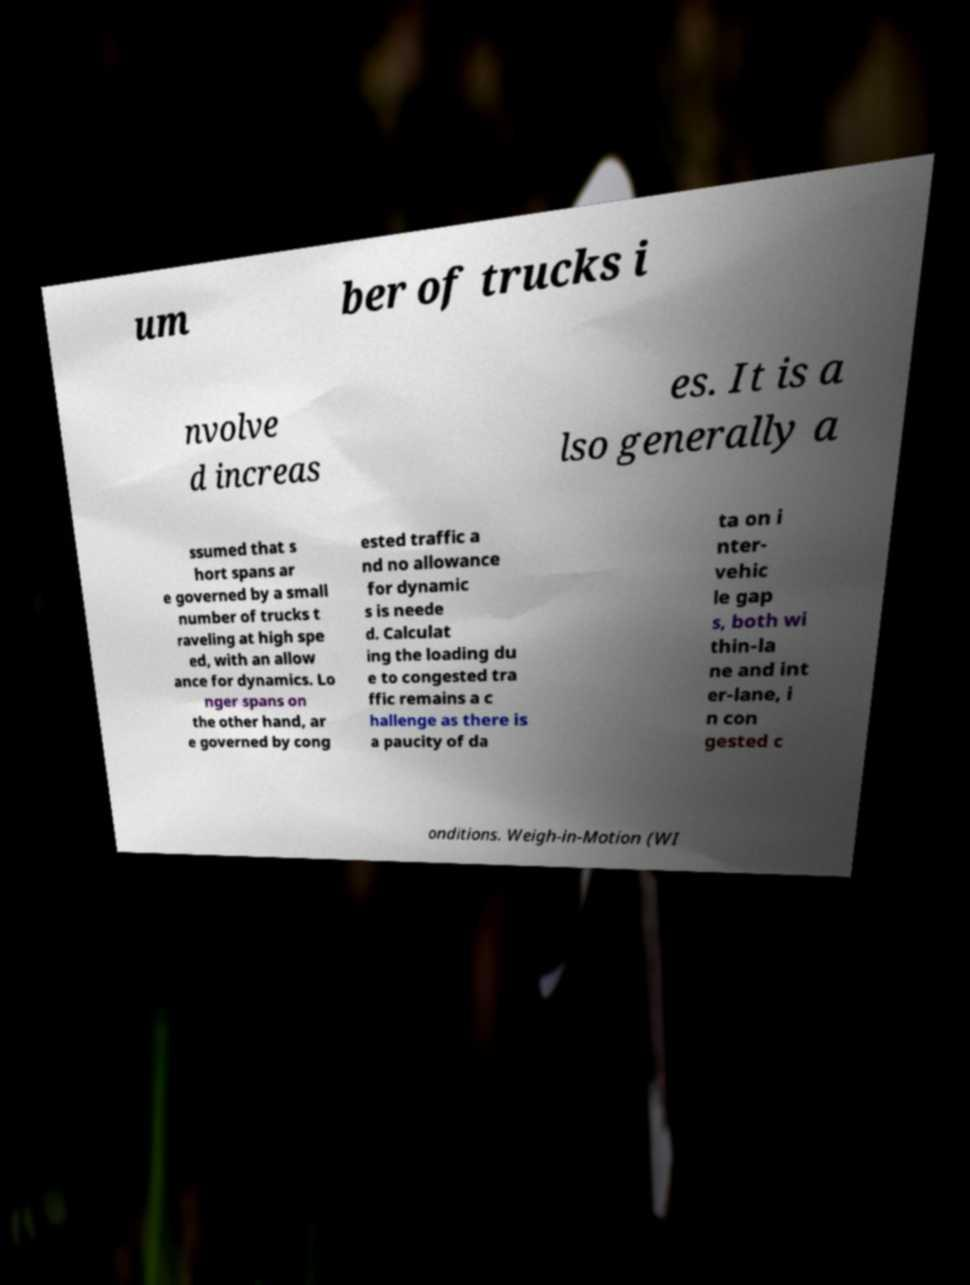What messages or text are displayed in this image? I need them in a readable, typed format. um ber of trucks i nvolve d increas es. It is a lso generally a ssumed that s hort spans ar e governed by a small number of trucks t raveling at high spe ed, with an allow ance for dynamics. Lo nger spans on the other hand, ar e governed by cong ested traffic a nd no allowance for dynamic s is neede d. Calculat ing the loading du e to congested tra ffic remains a c hallenge as there is a paucity of da ta on i nter- vehic le gap s, both wi thin-la ne and int er-lane, i n con gested c onditions. Weigh-in-Motion (WI 